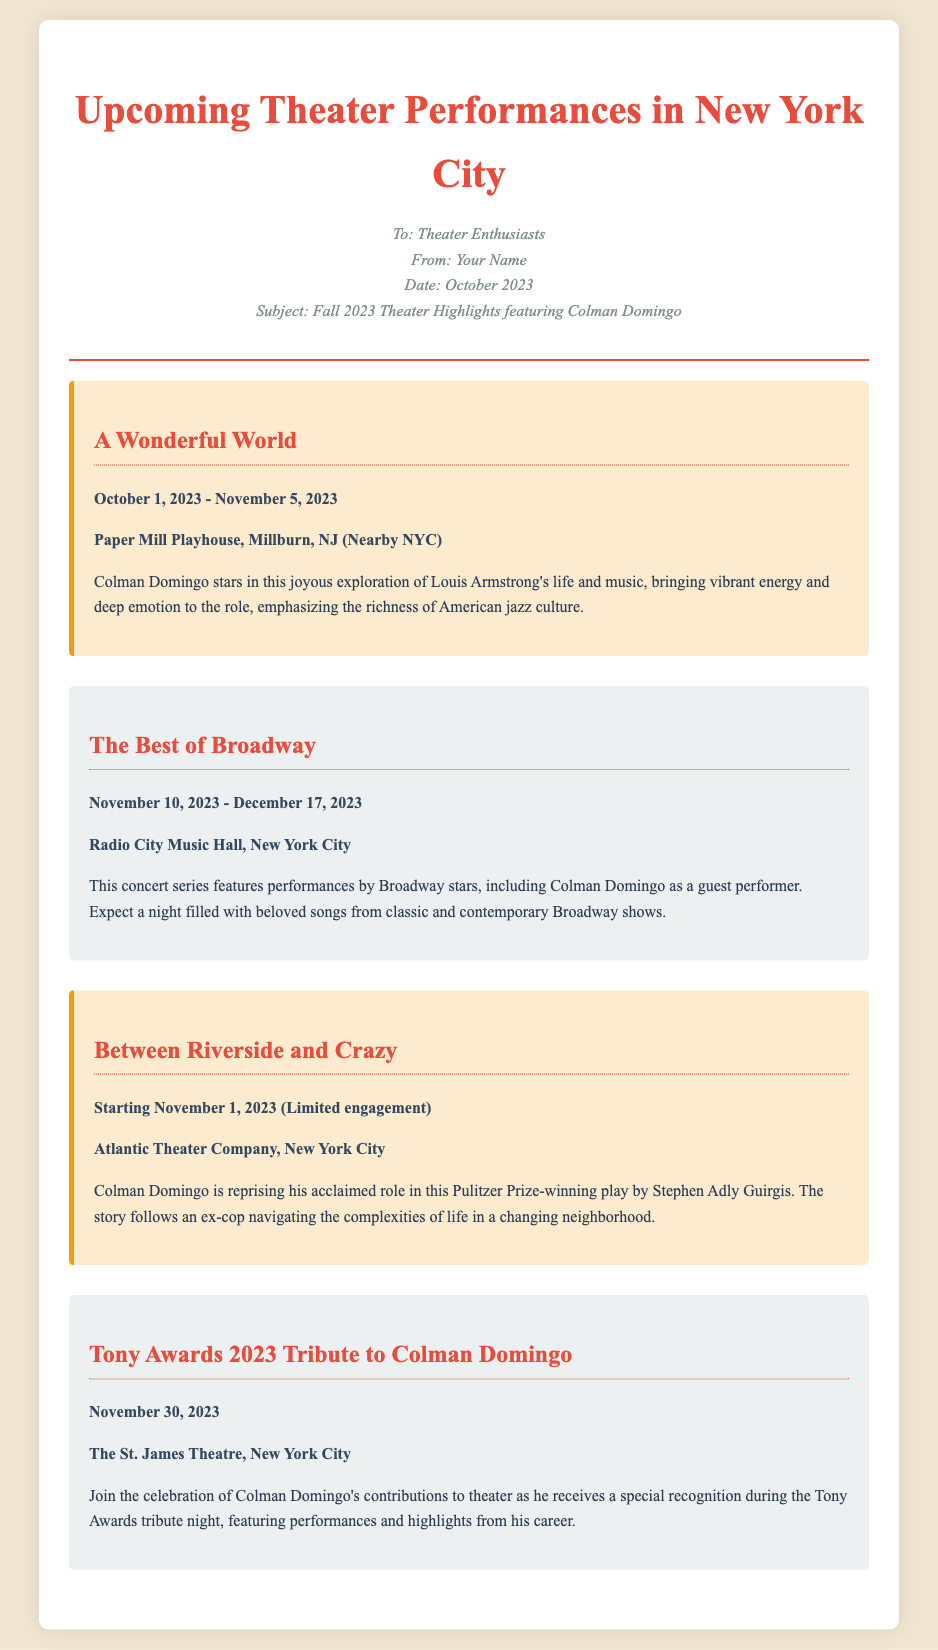What is the title of Colman Domingo's show in October 2023? The title of the show featuring Colman Domingo is provided in the document for the specified date, which is "A Wonderful World."
Answer: A Wonderful World Where is "The Best of Broadway" performed? The document clearly states the location for this performance, which is "Radio City Music Hall, New York City."
Answer: Radio City Music Hall, New York City When does "Between Riverside and Crazy" start? The starting date for this performance can be found in the document, stated as "Starting November 1, 2023."
Answer: Starting November 1, 2023 How long is "A Wonderful World" running? The document lists the performance period and the duration from October 1, 2023 to November 5, 2023, which gives the specific timeframe of the show.
Answer: October 1, 2023 - November 5, 2023 What special recognition will Colman Domingo receive on November 30, 2023? The document notes that Colman Domingo will receive a "special recognition" during the Tony Awards tribute night.
Answer: special recognition Why is "Between Riverside and Crazy" significant? This performance is described in the document as a Pulitzer Prize-winning play, highlighting its importance in theater.
Answer: Pulitzer Prize-winning How many performances involving Colman Domingo occur in November? The document outlines specific performances in November, counting the occurrences related to Colman Domingo, including "Between Riverside and Crazy" and "The Best of Broadway."
Answer: Three 